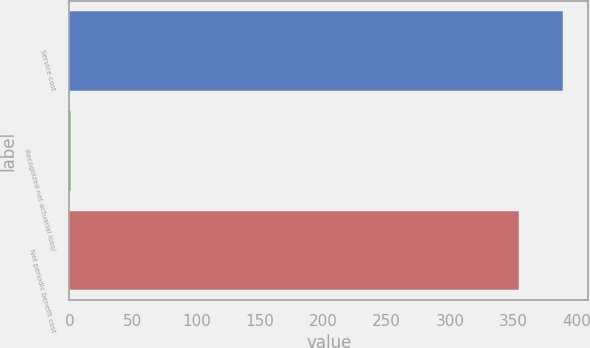Convert chart to OTSL. <chart><loc_0><loc_0><loc_500><loc_500><bar_chart><fcel>Service cost<fcel>Recognized net actuarial loss/<fcel>Net periodic benefit cost<nl><fcel>389.4<fcel>1<fcel>354<nl></chart> 